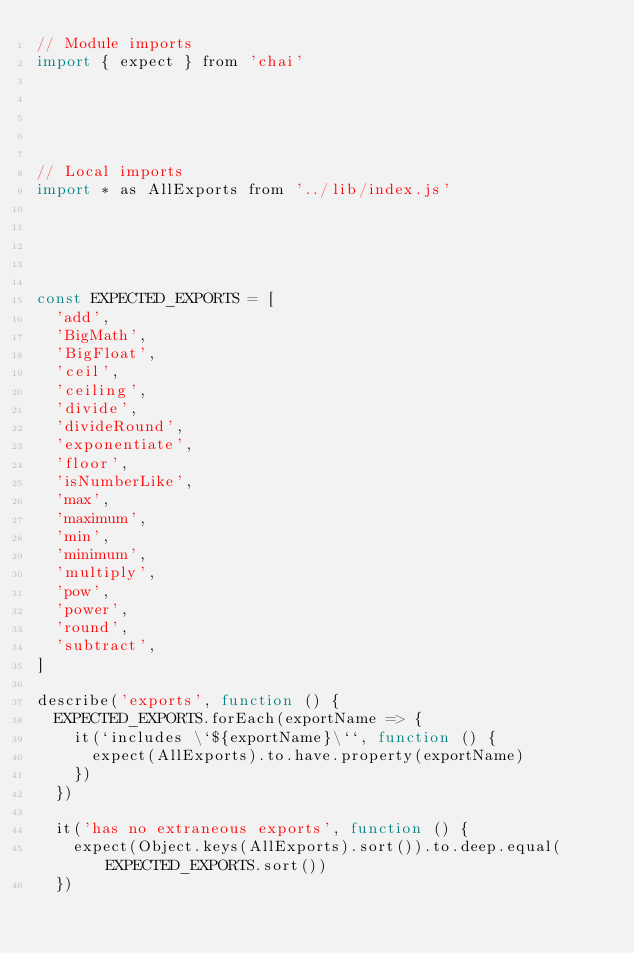Convert code to text. <code><loc_0><loc_0><loc_500><loc_500><_JavaScript_>// Module imports
import { expect } from 'chai'





// Local imports
import * as AllExports from '../lib/index.js'





const EXPECTED_EXPORTS = [
  'add',
  'BigMath',
  'BigFloat',
  'ceil',
  'ceiling',
  'divide',
  'divideRound',
  'exponentiate',
  'floor',
  'isNumberLike',
  'max',
  'maximum',
  'min',
  'minimum',
  'multiply',
  'pow',
  'power',
  'round',
  'subtract',
]

describe('exports', function () {
  EXPECTED_EXPORTS.forEach(exportName => {
    it(`includes \`${exportName}\``, function () {
      expect(AllExports).to.have.property(exportName)
    })
  })

  it('has no extraneous exports', function () {
    expect(Object.keys(AllExports).sort()).to.deep.equal(EXPECTED_EXPORTS.sort())
  })</code> 